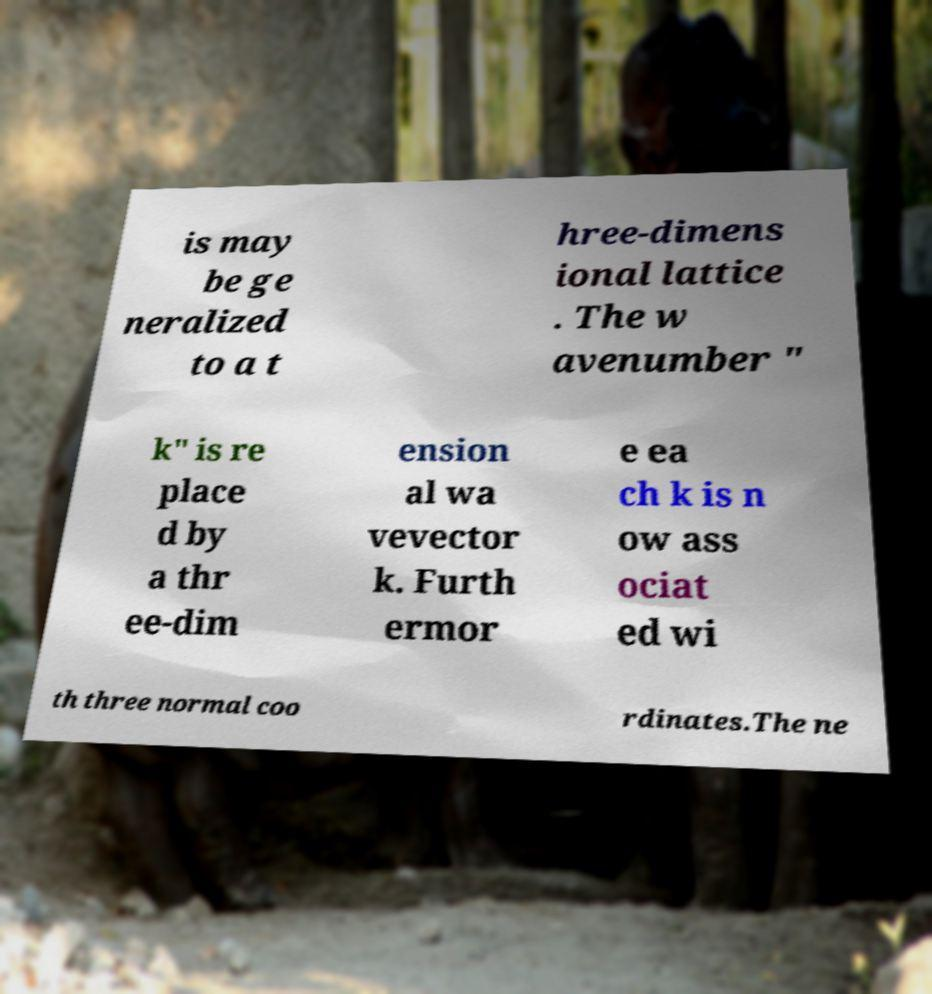Can you read and provide the text displayed in the image?This photo seems to have some interesting text. Can you extract and type it out for me? is may be ge neralized to a t hree-dimens ional lattice . The w avenumber " k" is re place d by a thr ee-dim ension al wa vevector k. Furth ermor e ea ch k is n ow ass ociat ed wi th three normal coo rdinates.The ne 